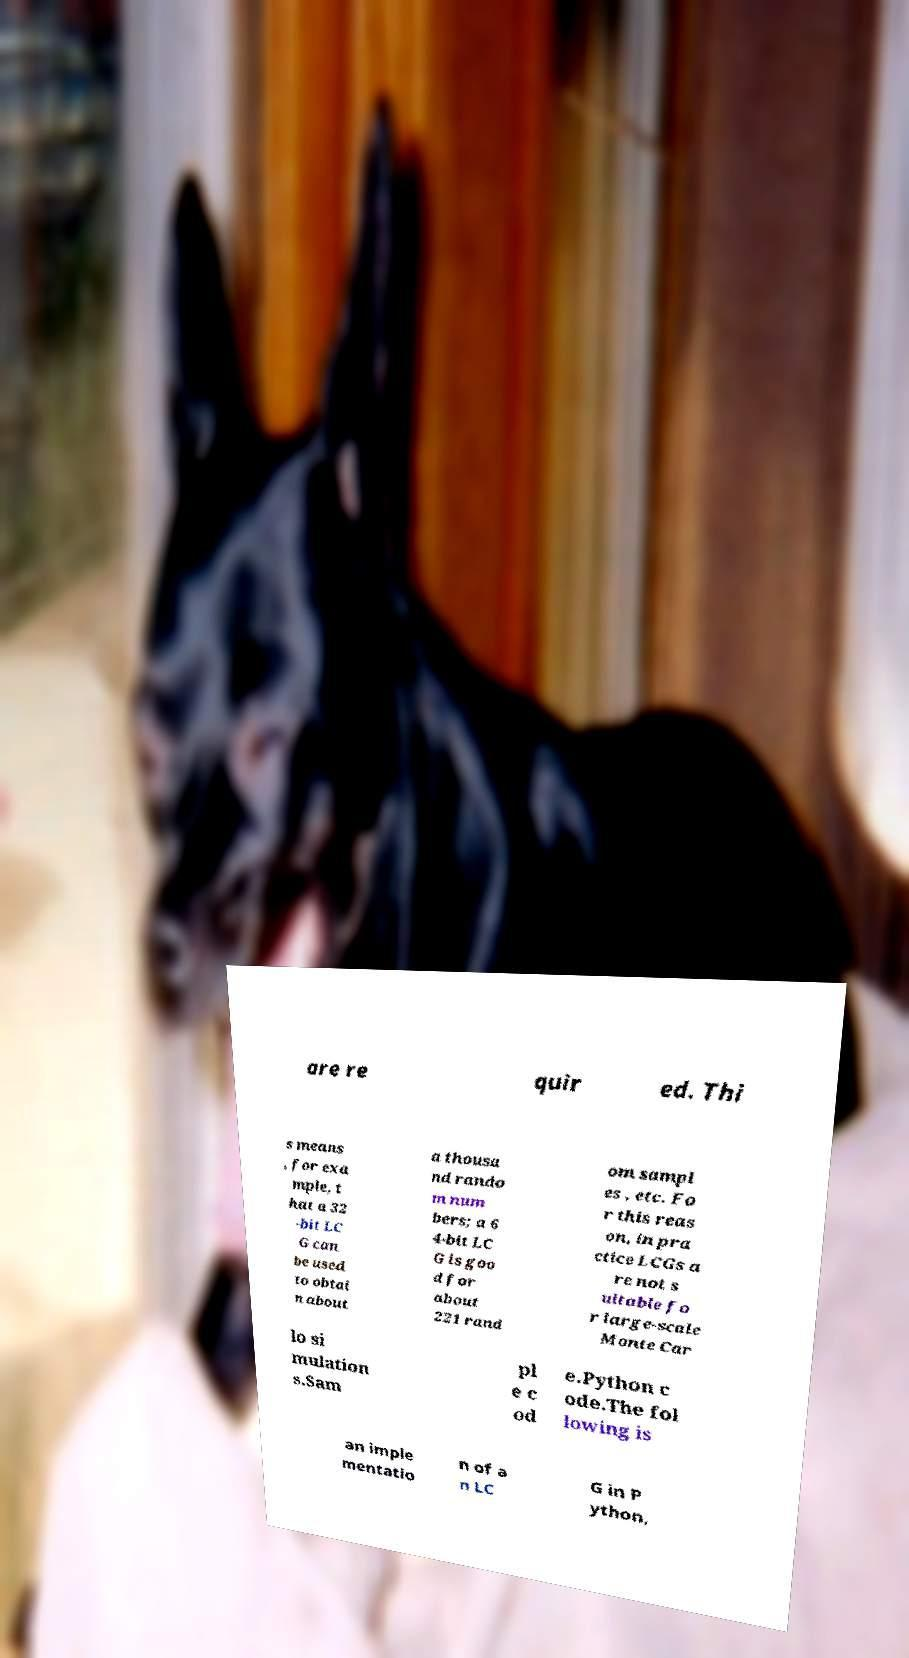What messages or text are displayed in this image? I need them in a readable, typed format. are re quir ed. Thi s means , for exa mple, t hat a 32 -bit LC G can be used to obtai n about a thousa nd rando m num bers; a 6 4-bit LC G is goo d for about 221 rand om sampl es , etc. Fo r this reas on, in pra ctice LCGs a re not s uitable fo r large-scale Monte Car lo si mulation s.Sam pl e c od e.Python c ode.The fol lowing is an imple mentatio n of a n LC G in P ython, 